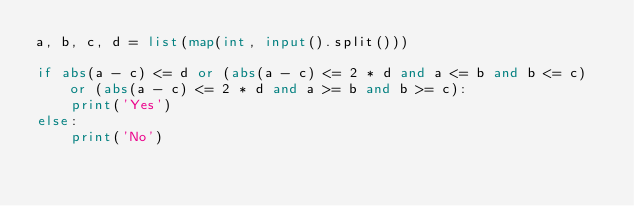Convert code to text. <code><loc_0><loc_0><loc_500><loc_500><_Python_>a, b, c, d = list(map(int, input().split()))

if abs(a - c) <= d or (abs(a - c) <= 2 * d and a <= b and b <= c) or (abs(a - c) <= 2 * d and a >= b and b >= c):
    print('Yes')
else:
    print('No')
</code> 